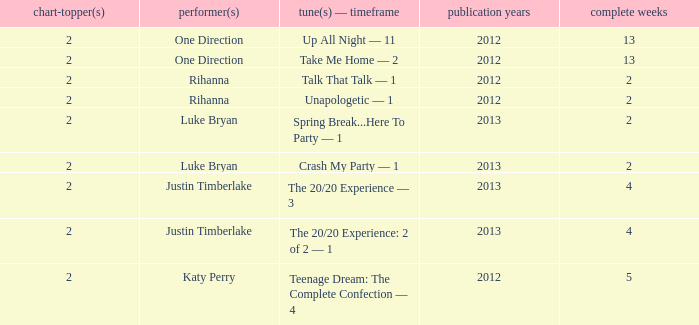What is the title of every song, and how many weeks was each song at #1 for One Direction? Up All Night — 11, Take Me Home — 2. 